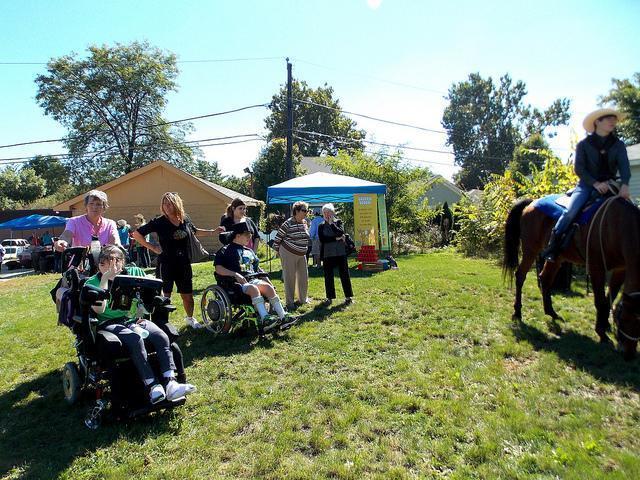How many people are in a wheelchair?
Give a very brief answer. 2. How many people are riding an animal?
Give a very brief answer. 1. How many people are there?
Give a very brief answer. 7. 